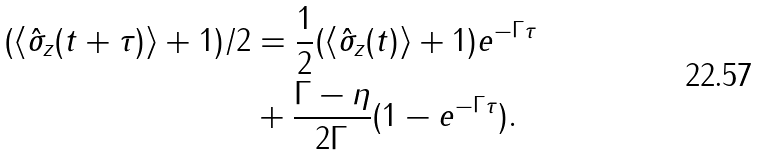<formula> <loc_0><loc_0><loc_500><loc_500>( \langle \hat { \sigma } _ { z } ( t + \tau ) \rangle + 1 ) / 2 & = \frac { 1 } { 2 } ( \langle \hat { \sigma } _ { z } ( t ) \rangle + 1 ) e ^ { - \Gamma \tau } \\ & + \frac { \Gamma - \eta } { 2 \Gamma } ( 1 - e ^ { - \Gamma \tau } ) .</formula> 